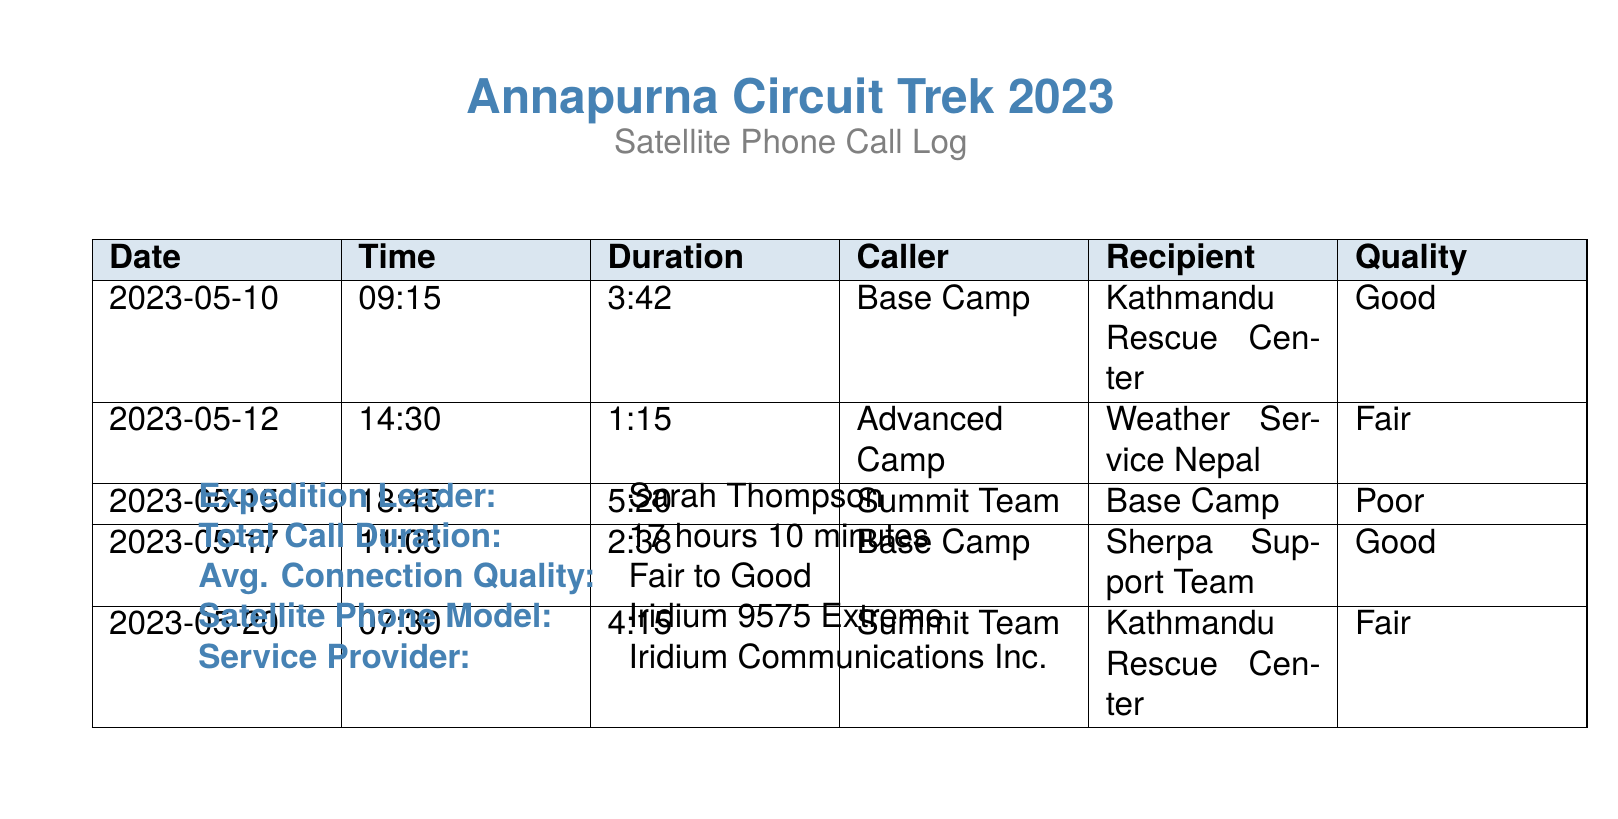What was the total call duration of the expedition? The total call duration is explicitly stated as 17 hours 10 minutes in the document.
Answer: 17 hours 10 minutes What is the quality of the call made on May 15th? The quality of the call on May 15th is mentioned in the call log, which states it was Poor.
Answer: Poor How long was the call to the Kathmandu Rescue Center on May 10th? The duration of the call on May 10th is indicated as 3:42 in the log.
Answer: 3:42 Who did the Advanced Camp contact on May 12th? The recipient of the call from Advanced Camp on May 12th is Weather Service Nepal, as recorded in the log.
Answer: Weather Service Nepal What is the average connection quality noted in the details? The document specifies the average connection quality as Fair to Good.
Answer: Fair to Good How many calls had a good connection quality? The number of calls with 'Good' quality can be counted from the log, totaling 2 calls.
Answer: 2 What was the caller for the call on May 17th? The call on May 17th was made from Base Camp, as shown in the log.
Answer: Base Camp What satellite phone model was used during the expedition? The document specifies the model used as Iridium 9575 Extreme.
Answer: Iridium 9575 Extreme Who was the expedition leader? The name of the expedition leader is Sarah Thompson, as stated in the document.
Answer: Sarah Thompson 